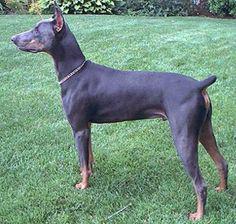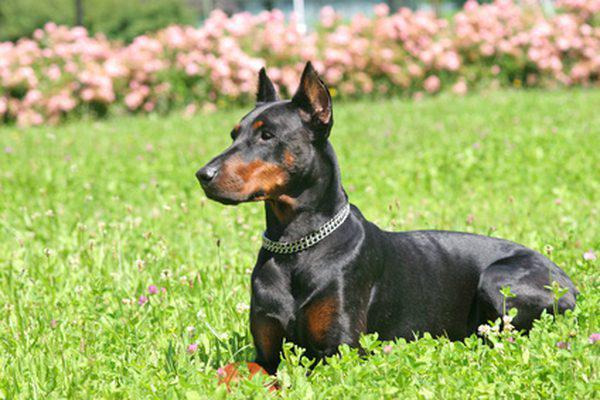The first image is the image on the left, the second image is the image on the right. Examine the images to the left and right. Is the description "One image shows a doberman with erect ears and docked tail standing in profile facing left, and the other image shows a non-standing doberman wearing a collar." accurate? Answer yes or no. Yes. The first image is the image on the left, the second image is the image on the right. Assess this claim about the two images: "One of the dogs is standing with its head facing left.". Correct or not? Answer yes or no. Yes. 